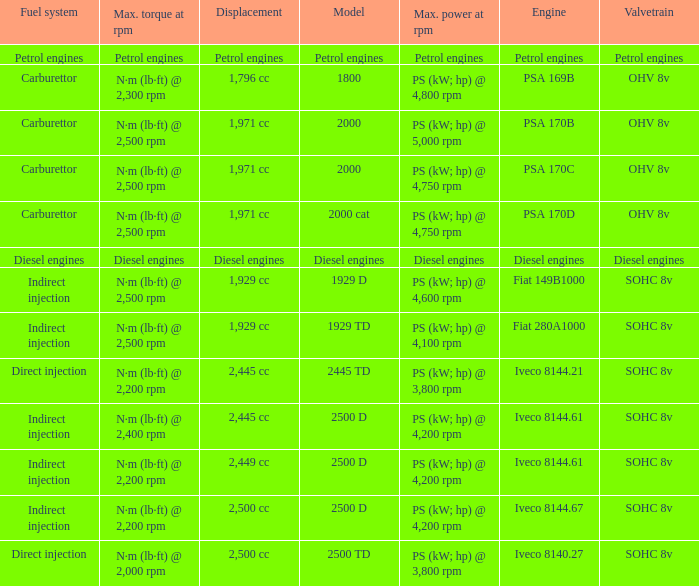What is the maximum torque that has 2,445 CC Displacement, and an Iveco 8144.61 engine? N·m (lb·ft) @ 2,400 rpm. 